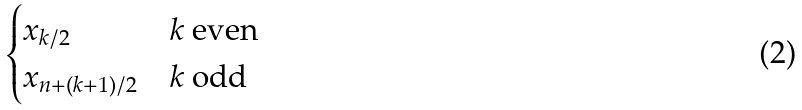Convert formula to latex. <formula><loc_0><loc_0><loc_500><loc_500>\begin{cases} x _ { k / 2 } & k \text { even} \\ x _ { n + ( k + 1 ) / 2 } & k \text { odd} \\ \end{cases}</formula> 